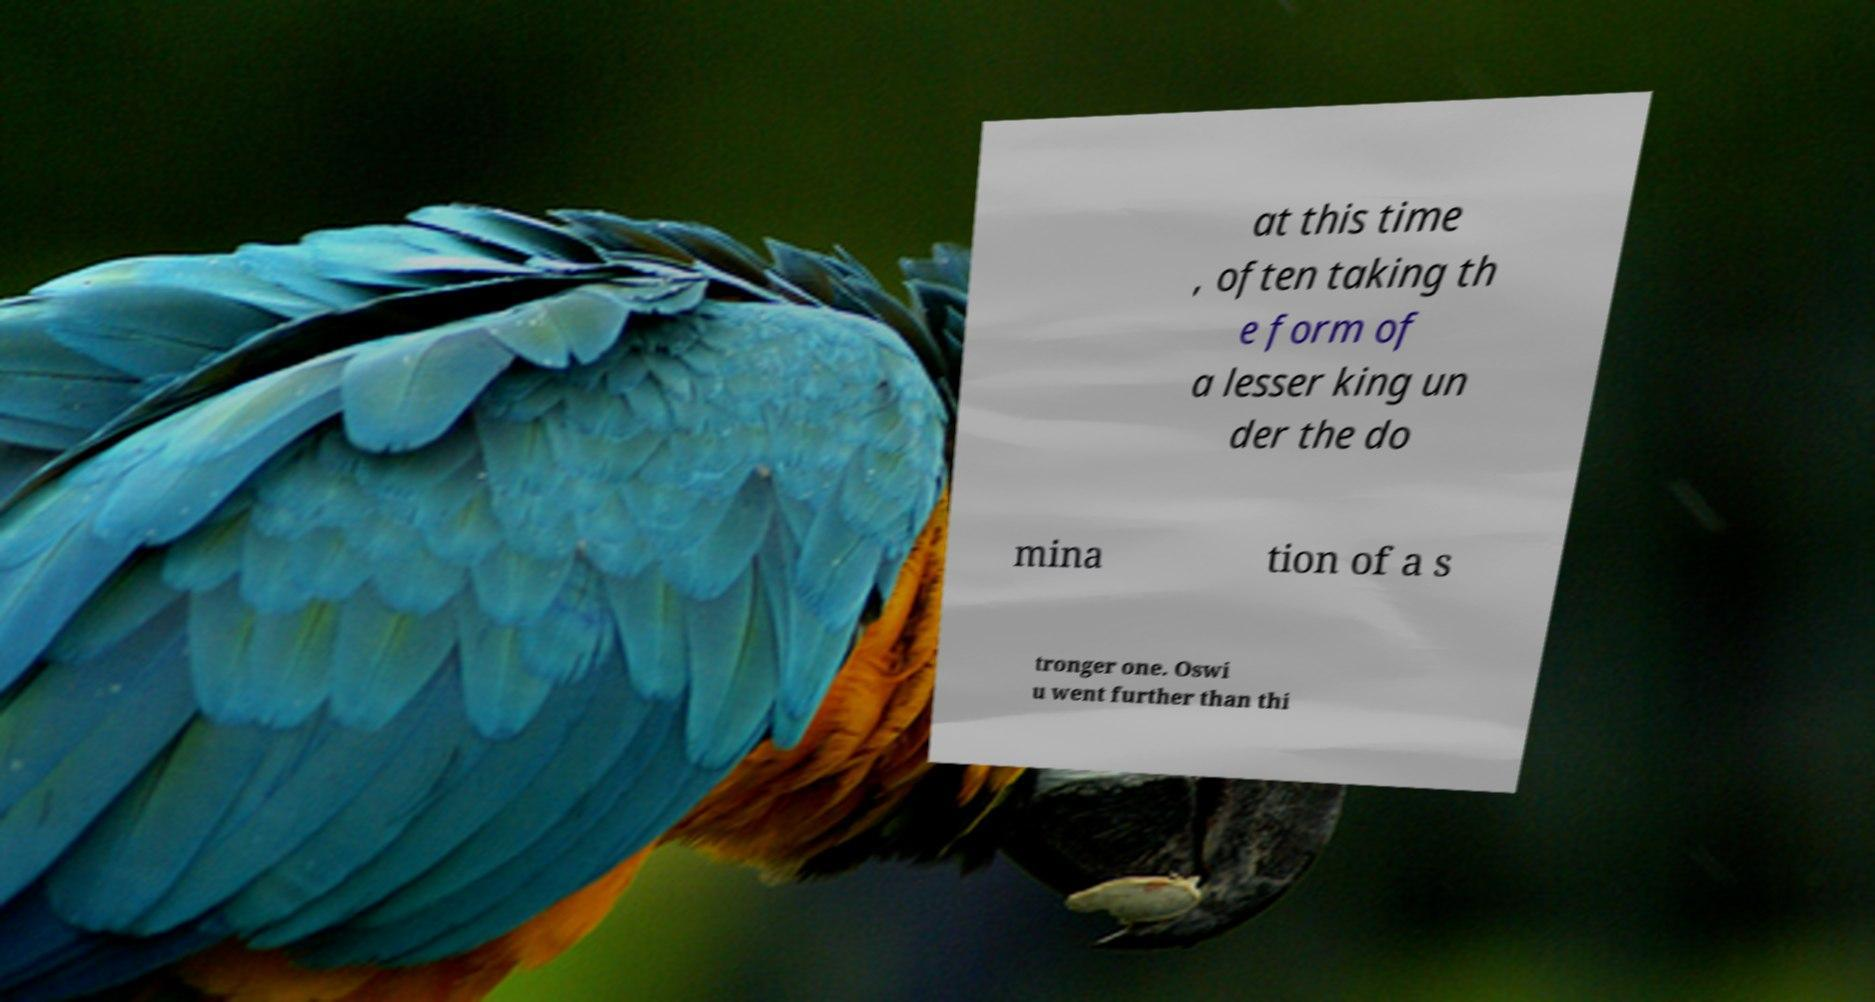Could you assist in decoding the text presented in this image and type it out clearly? at this time , often taking th e form of a lesser king un der the do mina tion of a s tronger one. Oswi u went further than thi 